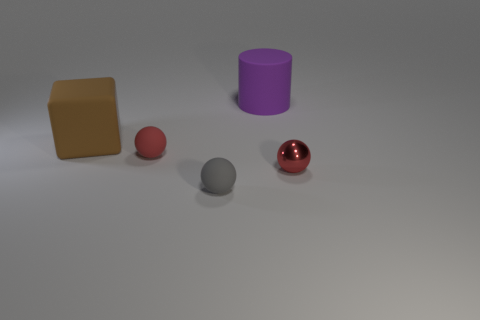There is a red metal ball to the right of the red matte ball; does it have the same size as the large brown rubber thing?
Give a very brief answer. No. There is a red sphere that is the same size as the red matte object; what material is it?
Keep it short and to the point. Metal. There is another red object that is the same shape as the red rubber thing; what is its material?
Offer a very short reply. Metal. How many other things are the same size as the purple cylinder?
Ensure brevity in your answer.  1. What size is the rubber object that is the same color as the metallic object?
Ensure brevity in your answer.  Small. What number of balls are the same color as the shiny object?
Your answer should be compact. 1. The tiny red metal thing is what shape?
Give a very brief answer. Sphere. What is the color of the matte object that is in front of the big brown rubber thing and right of the red matte ball?
Give a very brief answer. Gray. There is a object that is on the right side of the large rubber cylinder; what shape is it?
Provide a succinct answer. Sphere. What is the color of the metallic object that is the same size as the gray rubber object?
Give a very brief answer. Red. 